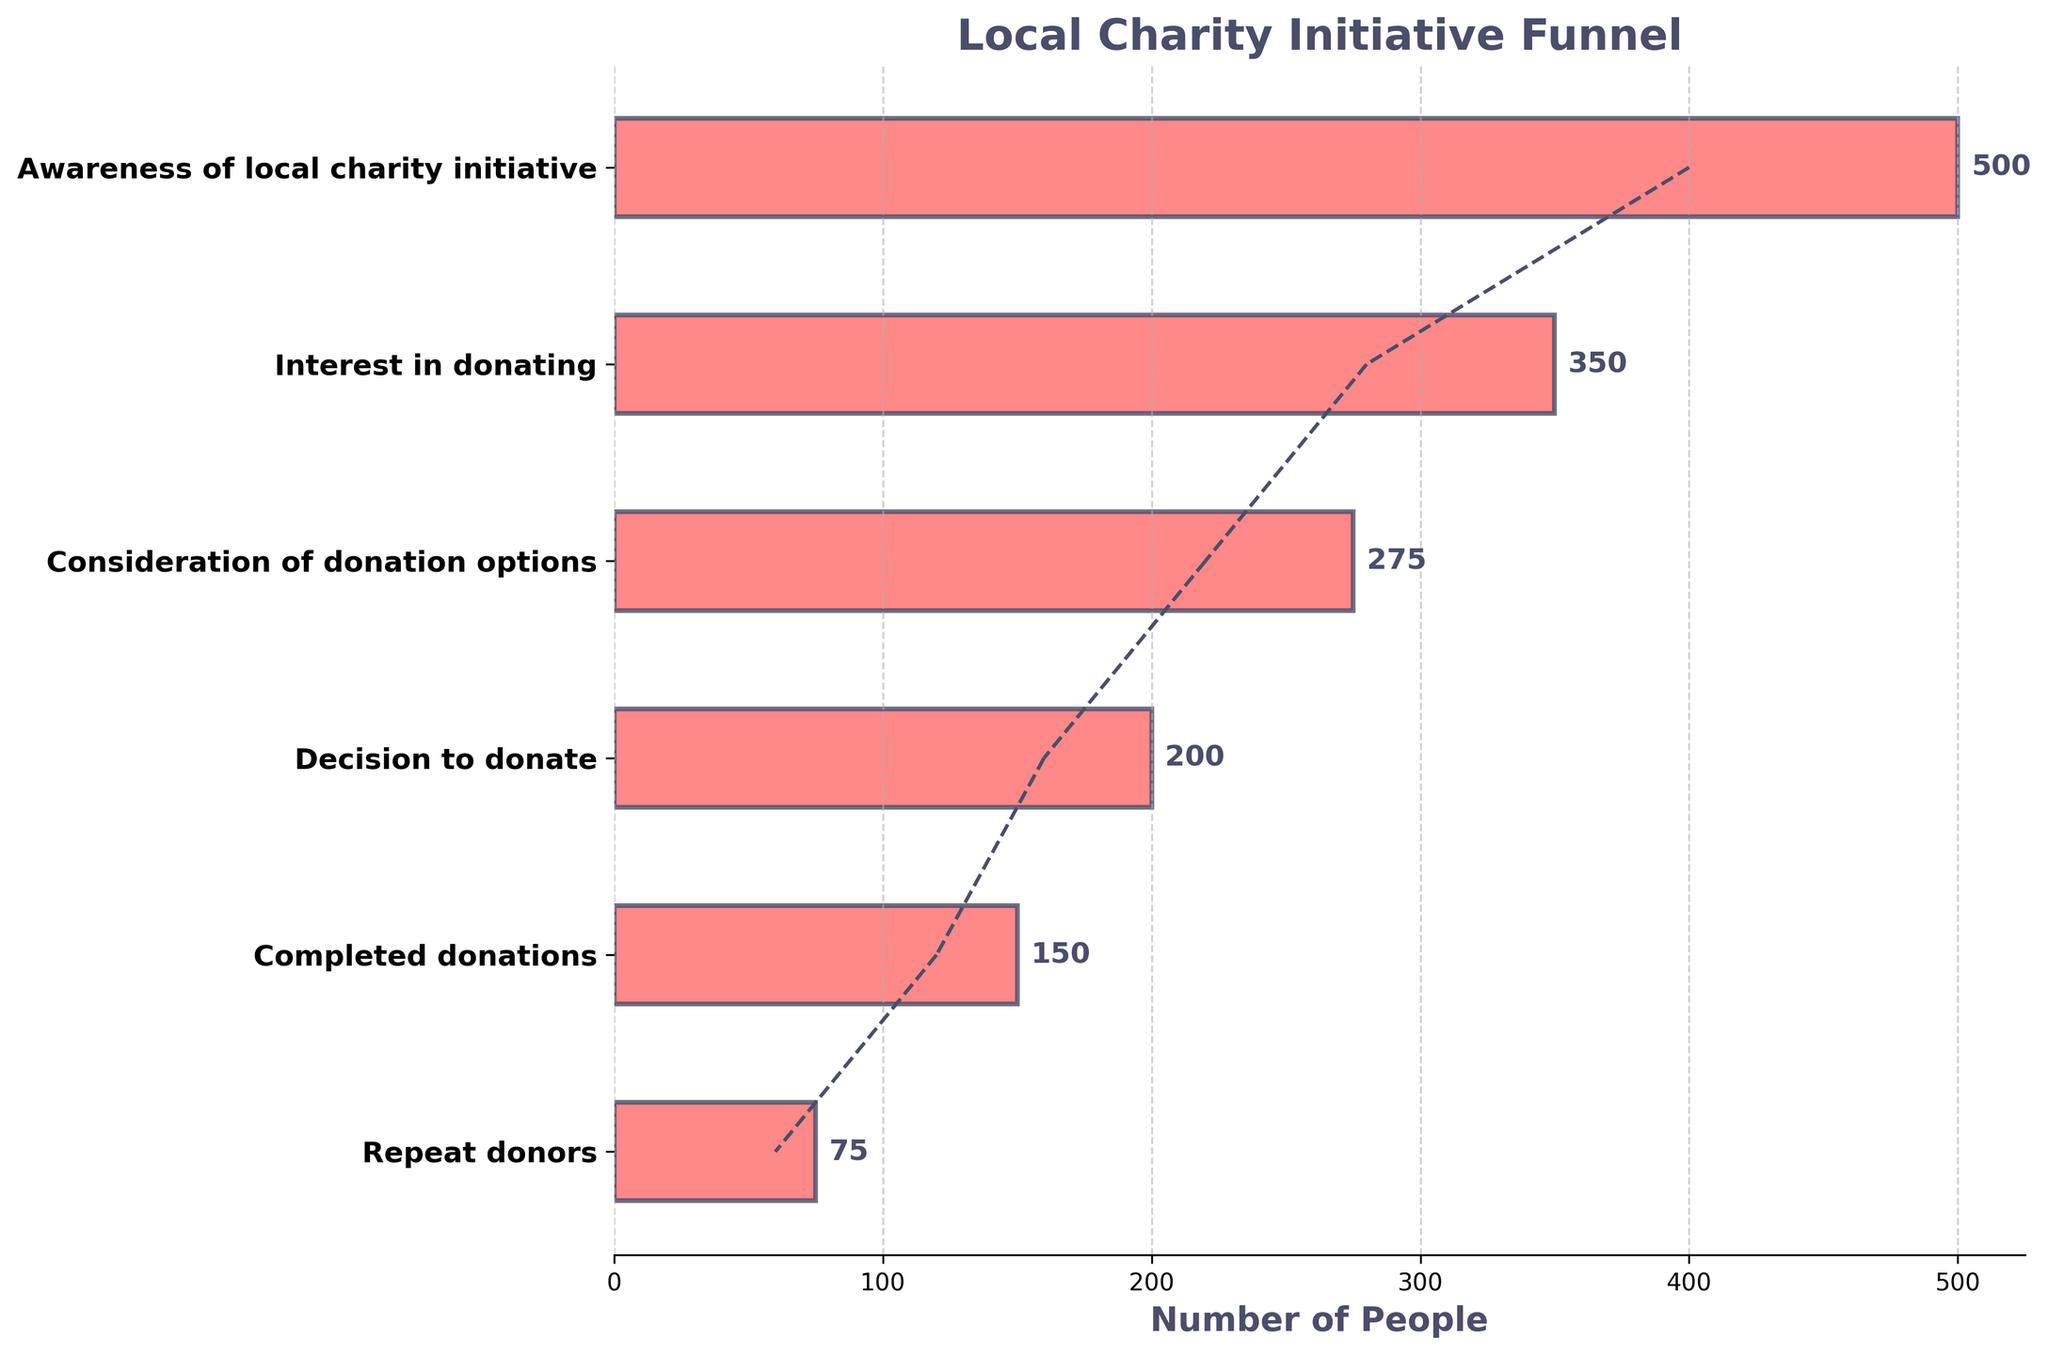What is the title of the figure? The title is located at the top of the figure in large, bold font. It provides an overview of the content of the chart.
Answer: Local Charity Initiative Funnel How many stages are shown in the funnel chart? The stages are listed on the y-axis of the figure, and each stage has a corresponding horizontal bar. Counting these gives the total number.
Answer: 6 What stage in the funnel has the highest number of people? Examine the length of each bar in the funnel. The longest bar represents the stage with the highest number of people.
Answer: Awareness of local charity initiative How many people completed donations? Locate the stage labeled "Completed donations" on the y-axis and read the number of people associated with this stage shown on the horizontal bar.
Answer: 150 Which stage has the lowest number of people? Compare the length of each bar. The shortest bar indicates the stage with the lowest number of people.
Answer: Repeat donors What is the difference between the number of people aware of the local charity initiative and those who completed donations? Identify the numbers at the "Awareness of local charity initiative" and "Completed donations" stages and subtract the second from the first: 500 - 150.
Answer: 350 What percentage of the people who decided to donate actually completed donations? Find the numbers for "Decision to donate" and "Completed donations". Divide the latter by the former and multiply by 100: (150 / 200) * 100.
Answer: 75% By how many people does interest in donating exceed the number of repeat donors? Identify the numbers for both "Interest in donating" and "Repeat donors" stages and subtract the second from the first: 350 - 75.
Answer: 275 What trend can be observed from the number of people at each stage of the funnel chart? Observe the progression from the top of the funnel to the bottom, noting how the number of people changes at each stage. The number of people decreases at each subsequent stage.
Answer: The number of people decreases at each subsequent stage 